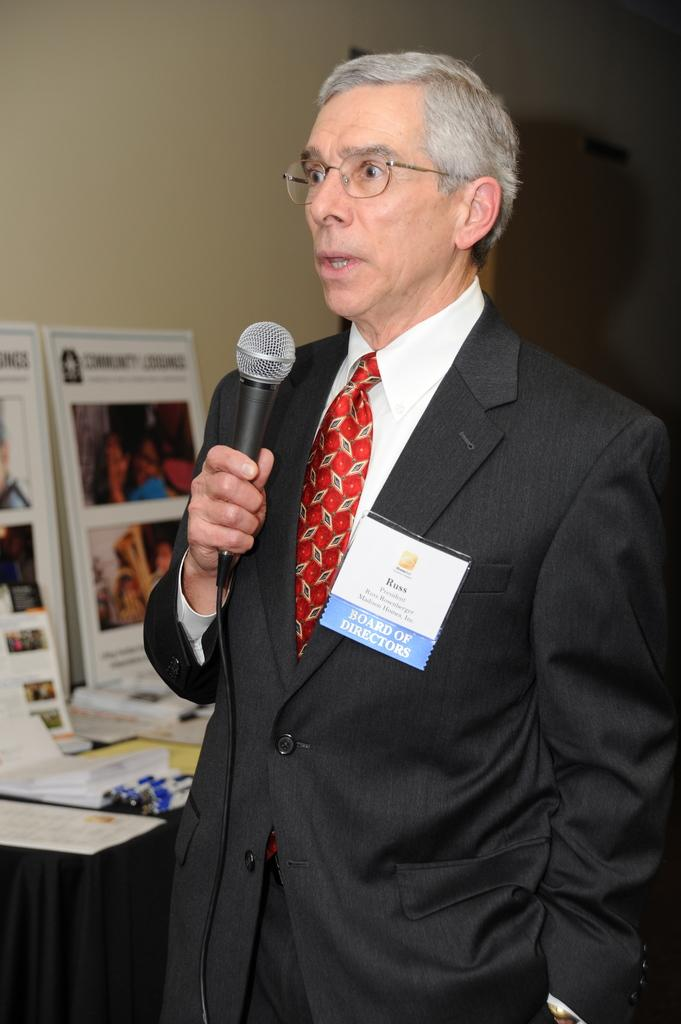What can be seen in the image? There is a person in the image. Can you describe the person's appearance? The person is wearing specs and a badge. What is the person holding in the image? The person is holding a mic. What is visible in the background of the image? There is a wall in the background of the image. What else can be seen in the image besides the person? There is a platform with posters in the image. What type of bag can be seen hanging from the person's shoulder in the image? There is no bag visible in the image; the person is only holding a mic and wearing specs and a badge. 